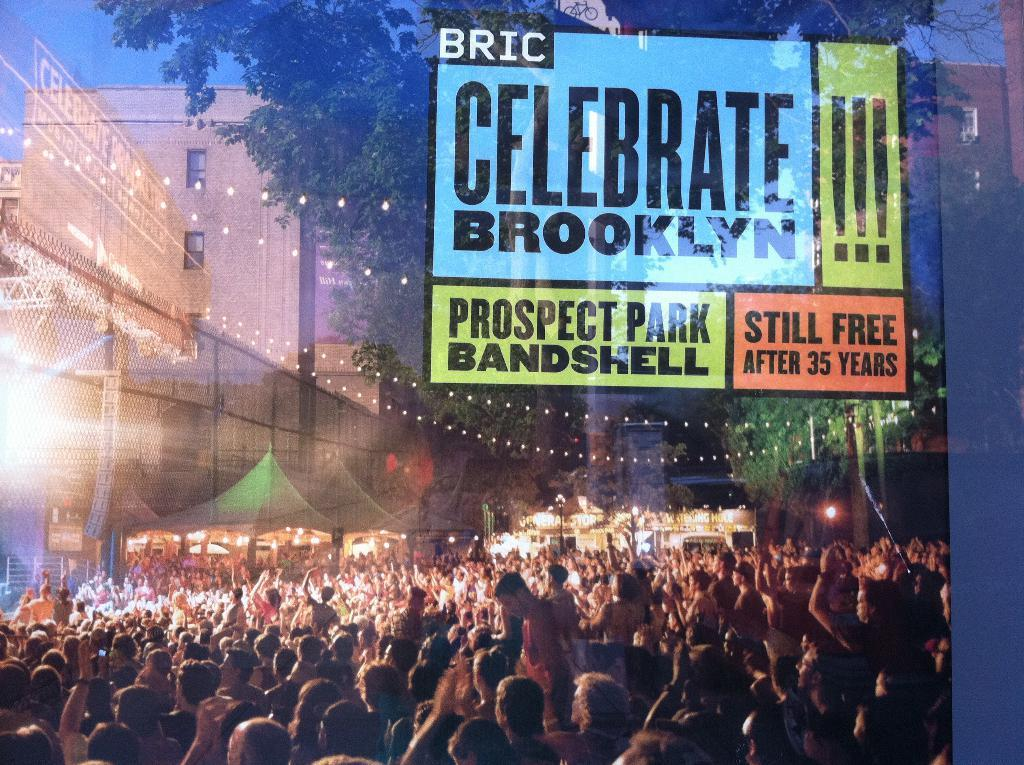<image>
Provide a brief description of the given image. A group of people with a celebrate Brooklyn sentiment above them 